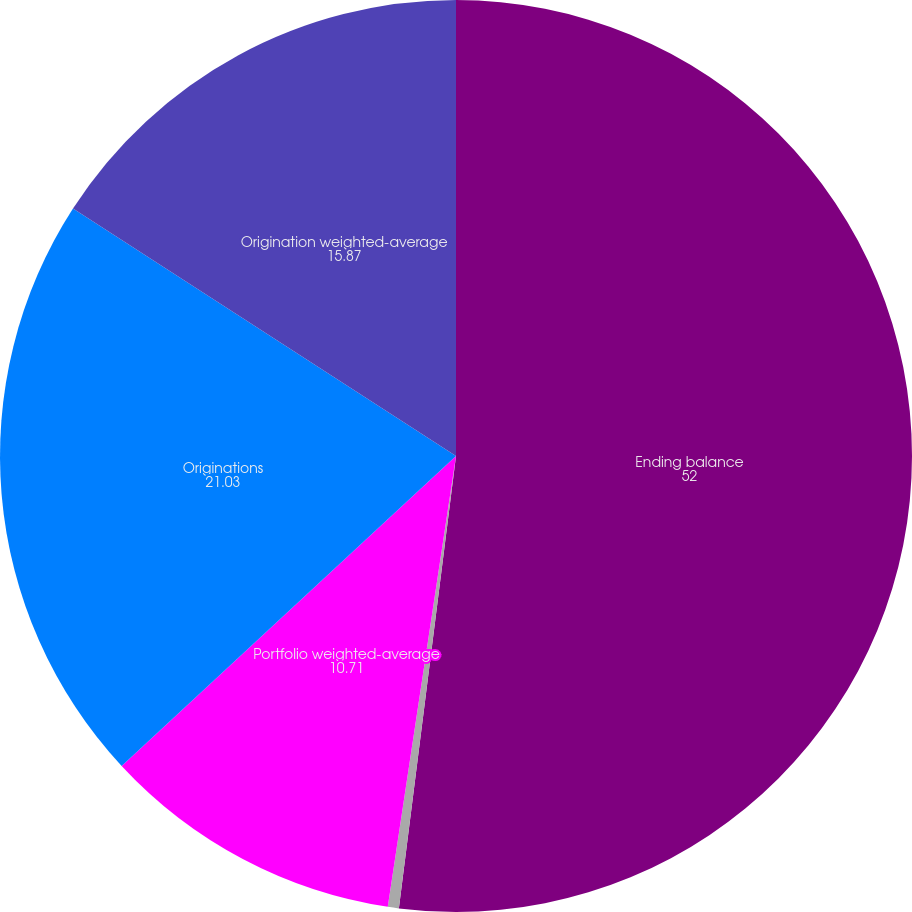Convert chart to OTSL. <chart><loc_0><loc_0><loc_500><loc_500><pie_chart><fcel>Ending balance<fcel>Portfolio weighted-average LTV<fcel>Portfolio weighted-average<fcel>Originations<fcel>Origination weighted-average<nl><fcel>52.0%<fcel>0.39%<fcel>10.71%<fcel>21.03%<fcel>15.87%<nl></chart> 